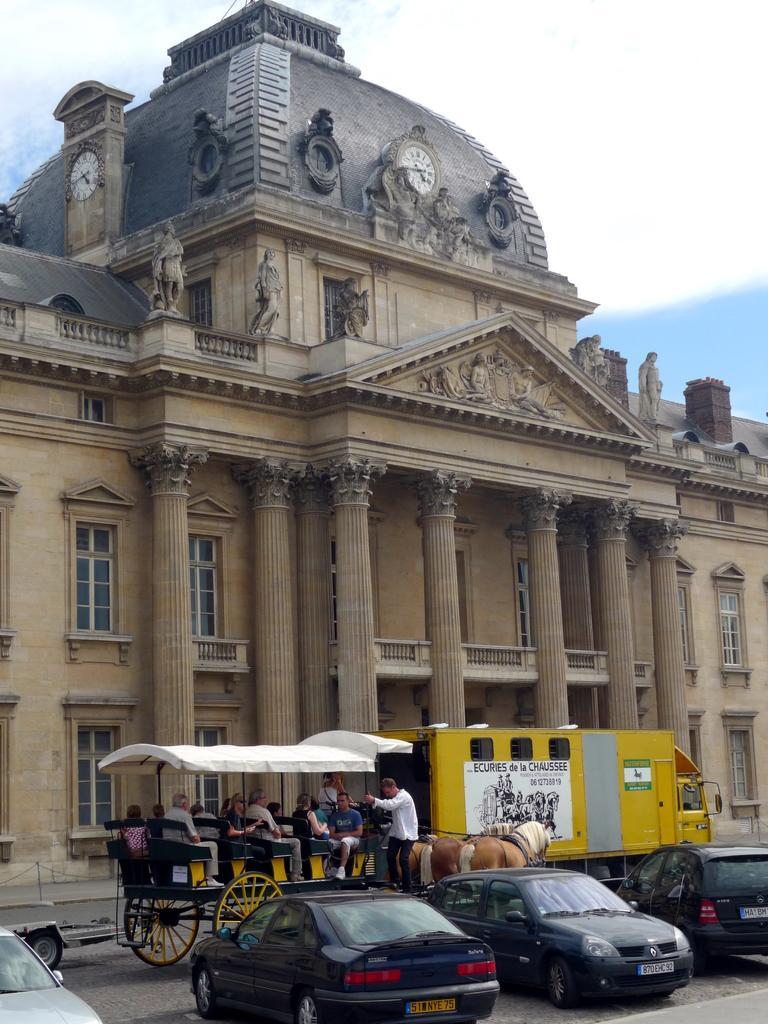How would you summarize this image in a sentence or two? In this image, we can see many cars at the bottom and on the right side we can see a yellow color vehicle, in the middle we can see a big building and there are many pillars and on the right side we can see horses and there are many people. 